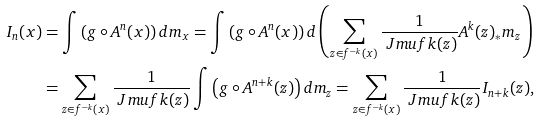Convert formula to latex. <formula><loc_0><loc_0><loc_500><loc_500>I _ { n } ( x ) & = \int \left ( g \circ A ^ { n } ( x ) \right ) d m _ { x } = \int \left ( g \circ A ^ { n } ( x ) \right ) d \left ( \sum _ { z \in f ^ { - k } ( x ) } \frac { 1 } { \ J m u f k ( z ) } A ^ { k } ( z ) _ { * } m _ { z } \right ) \\ & = \sum _ { z \in f ^ { - k } ( x ) } \frac { 1 } { \ J m u f k ( z ) } \int \left ( g \circ A ^ { n + k } ( z ) \right ) d m _ { z } = \sum _ { z \in f ^ { - k } ( x ) } \frac { 1 } { \ J m u f k ( z ) } I _ { n + k } ( z ) ,</formula> 